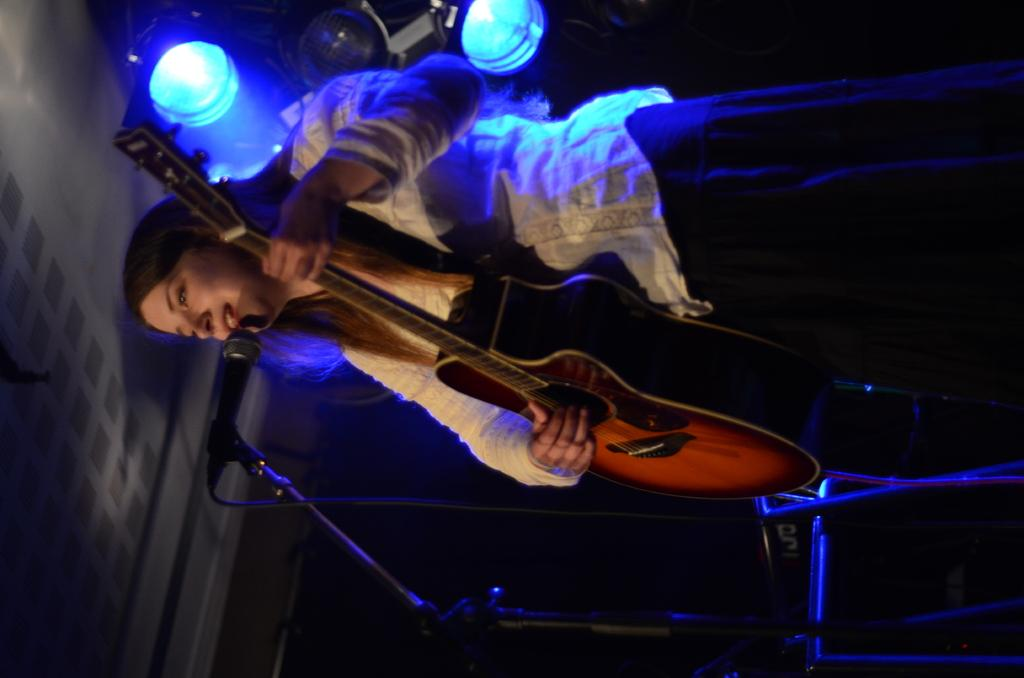Who is the main subject in the image? There is a woman in the image. What is the woman doing in the image? The woman is singing and playing a guitar. What tool is the woman using to amplify her voice? The woman is using a microphone in the image. What type of destruction can be seen happening to the desk in the image? There is no desk present in the image, and therefore no destruction can be observed. 